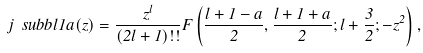<formula> <loc_0><loc_0><loc_500><loc_500>j \ s u b b l 1 a ( z ) = \frac { z ^ { l } } { ( 2 l + 1 ) ! ! } F \left ( \frac { l + 1 - a } 2 , \frac { l + 1 + a } 2 ; l + \frac { 3 } { 2 } ; - z ^ { 2 } \right ) ,</formula> 